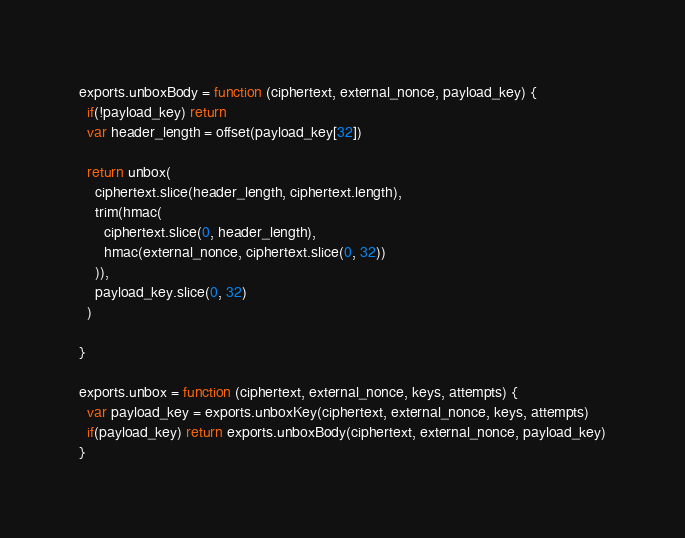<code> <loc_0><loc_0><loc_500><loc_500><_JavaScript_>
exports.unboxBody = function (ciphertext, external_nonce, payload_key) {
  if(!payload_key) return
  var header_length = offset(payload_key[32])

  return unbox(
    ciphertext.slice(header_length, ciphertext.length),
    trim(hmac(
      ciphertext.slice(0, header_length),
      hmac(external_nonce, ciphertext.slice(0, 32))
    )),
    payload_key.slice(0, 32)
  )

}

exports.unbox = function (ciphertext, external_nonce, keys, attempts) {
  var payload_key = exports.unboxKey(ciphertext, external_nonce, keys, attempts)
  if(payload_key) return exports.unboxBody(ciphertext, external_nonce, payload_key)
}

</code> 